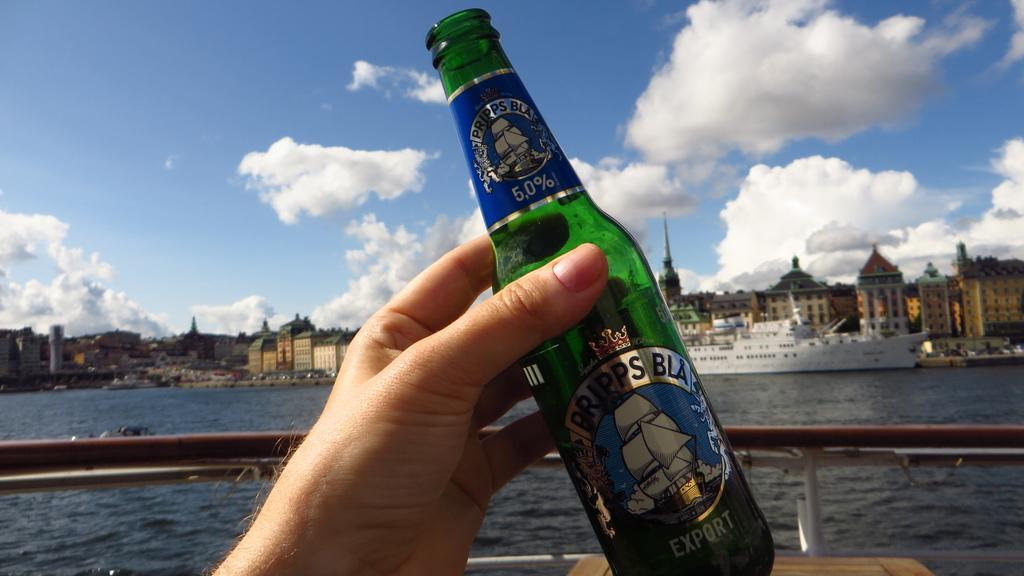Can you describe this image briefly? In the center we can see human hand holding bottle named as "Export". On the back we can see sky with clouds,buildings,ship and water. 